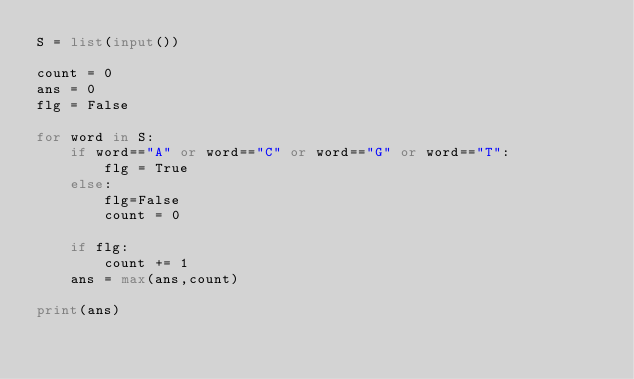Convert code to text. <code><loc_0><loc_0><loc_500><loc_500><_Python_>S = list(input())

count = 0
ans = 0
flg = False

for word in S:
    if word=="A" or word=="C" or word=="G" or word=="T":
        flg = True
    else:
        flg=False
        count = 0
    
    if flg:
        count += 1
    ans = max(ans,count)

print(ans)</code> 